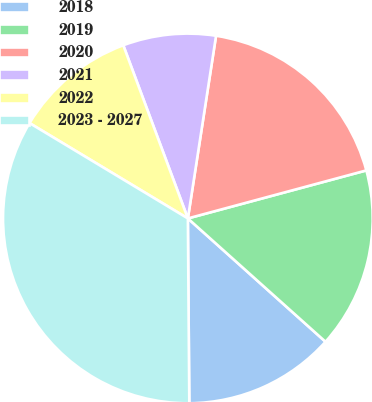<chart> <loc_0><loc_0><loc_500><loc_500><pie_chart><fcel>2018<fcel>2019<fcel>2020<fcel>2021<fcel>2022<fcel>2023 - 2027<nl><fcel>13.25%<fcel>15.81%<fcel>18.38%<fcel>8.12%<fcel>10.69%<fcel>33.75%<nl></chart> 